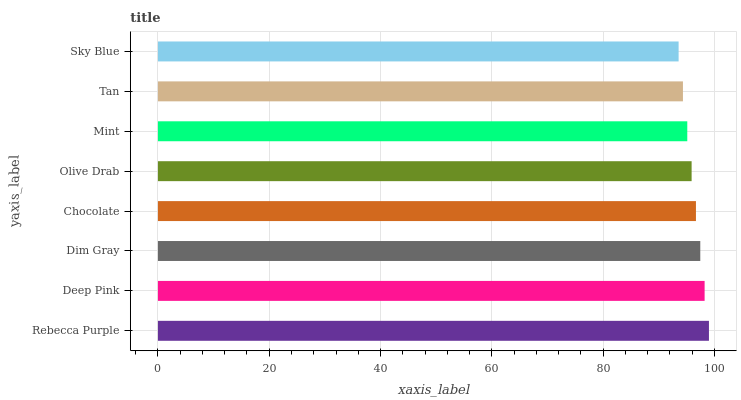Is Sky Blue the minimum?
Answer yes or no. Yes. Is Rebecca Purple the maximum?
Answer yes or no. Yes. Is Deep Pink the minimum?
Answer yes or no. No. Is Deep Pink the maximum?
Answer yes or no. No. Is Rebecca Purple greater than Deep Pink?
Answer yes or no. Yes. Is Deep Pink less than Rebecca Purple?
Answer yes or no. Yes. Is Deep Pink greater than Rebecca Purple?
Answer yes or no. No. Is Rebecca Purple less than Deep Pink?
Answer yes or no. No. Is Chocolate the high median?
Answer yes or no. Yes. Is Olive Drab the low median?
Answer yes or no. Yes. Is Deep Pink the high median?
Answer yes or no. No. Is Dim Gray the low median?
Answer yes or no. No. 